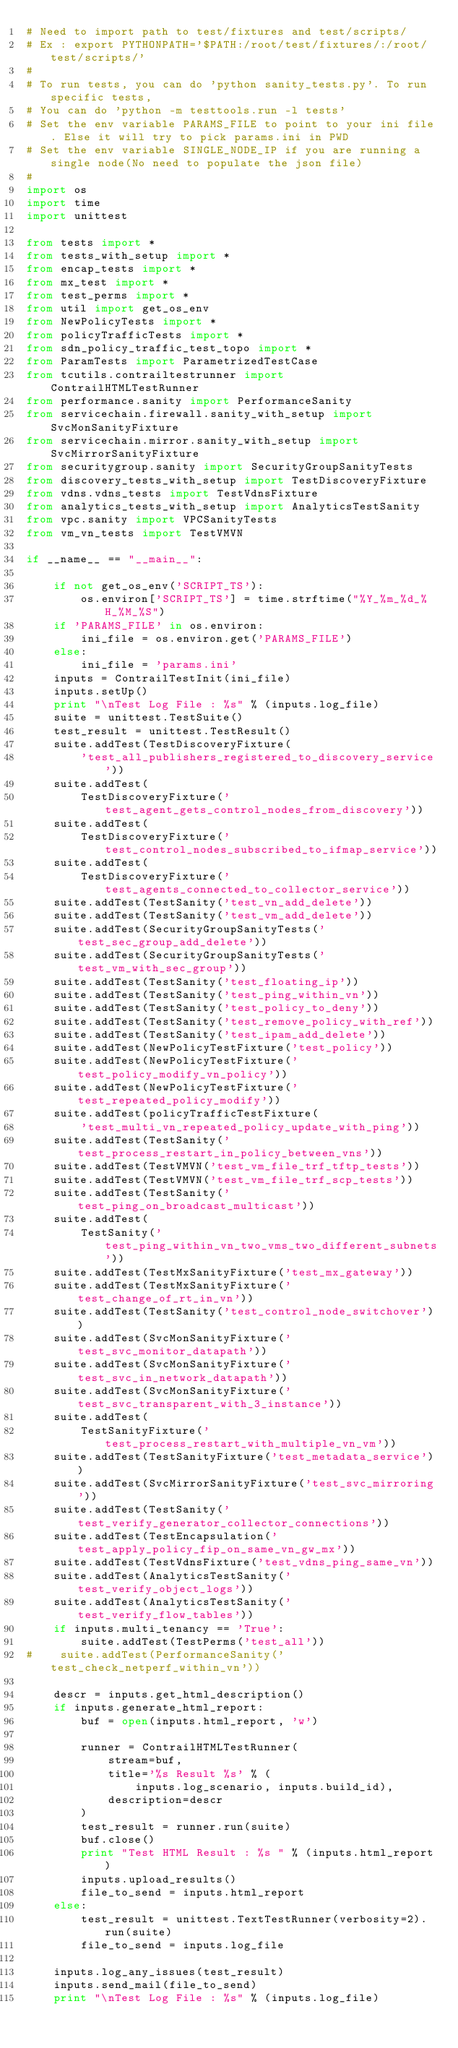<code> <loc_0><loc_0><loc_500><loc_500><_Python_># Need to import path to test/fixtures and test/scripts/
# Ex : export PYTHONPATH='$PATH:/root/test/fixtures/:/root/test/scripts/'
#
# To run tests, you can do 'python sanity_tests.py'. To run specific tests,
# You can do 'python -m testtools.run -l tests'
# Set the env variable PARAMS_FILE to point to your ini file. Else it will try to pick params.ini in PWD
# Set the env variable SINGLE_NODE_IP if you are running a single node(No need to populate the json file)
#
import os
import time
import unittest

from tests import *
from tests_with_setup import *
from encap_tests import *
from mx_test import *
from test_perms import *
from util import get_os_env
from NewPolicyTests import *
from policyTrafficTests import *
from sdn_policy_traffic_test_topo import *
from ParamTests import ParametrizedTestCase
from tcutils.contrailtestrunner import ContrailHTMLTestRunner
from performance.sanity import PerformanceSanity
from servicechain.firewall.sanity_with_setup import SvcMonSanityFixture
from servicechain.mirror.sanity_with_setup import SvcMirrorSanityFixture
from securitygroup.sanity import SecurityGroupSanityTests
from discovery_tests_with_setup import TestDiscoveryFixture
from vdns.vdns_tests import TestVdnsFixture
from analytics_tests_with_setup import AnalyticsTestSanity
from vpc.sanity import VPCSanityTests
from vm_vn_tests import TestVMVN

if __name__ == "__main__":

    if not get_os_env('SCRIPT_TS'):
        os.environ['SCRIPT_TS'] = time.strftime("%Y_%m_%d_%H_%M_%S")
    if 'PARAMS_FILE' in os.environ:
        ini_file = os.environ.get('PARAMS_FILE')
    else:
        ini_file = 'params.ini'
    inputs = ContrailTestInit(ini_file)
    inputs.setUp()
    print "\nTest Log File : %s" % (inputs.log_file)
    suite = unittest.TestSuite()
    test_result = unittest.TestResult()
    suite.addTest(TestDiscoveryFixture(
        'test_all_publishers_registered_to_discovery_service'))
    suite.addTest(
        TestDiscoveryFixture('test_agent_gets_control_nodes_from_discovery'))
    suite.addTest(
        TestDiscoveryFixture('test_control_nodes_subscribed_to_ifmap_service'))
    suite.addTest(
        TestDiscoveryFixture('test_agents_connected_to_collector_service'))
    suite.addTest(TestSanity('test_vn_add_delete'))
    suite.addTest(TestSanity('test_vm_add_delete'))
    suite.addTest(SecurityGroupSanityTests('test_sec_group_add_delete'))
    suite.addTest(SecurityGroupSanityTests('test_vm_with_sec_group'))
    suite.addTest(TestSanity('test_floating_ip'))
    suite.addTest(TestSanity('test_ping_within_vn'))
    suite.addTest(TestSanity('test_policy_to_deny'))
    suite.addTest(TestSanity('test_remove_policy_with_ref'))
    suite.addTest(TestSanity('test_ipam_add_delete'))
    suite.addTest(NewPolicyTestFixture('test_policy'))
    suite.addTest(NewPolicyTestFixture('test_policy_modify_vn_policy'))
    suite.addTest(NewPolicyTestFixture('test_repeated_policy_modify'))
    suite.addTest(policyTrafficTestFixture(
        'test_multi_vn_repeated_policy_update_with_ping'))
    suite.addTest(TestSanity('test_process_restart_in_policy_between_vns'))
    suite.addTest(TestVMVN('test_vm_file_trf_tftp_tests'))
    suite.addTest(TestVMVN('test_vm_file_trf_scp_tests'))
    suite.addTest(TestSanity('test_ping_on_broadcast_multicast'))
    suite.addTest(
        TestSanity('test_ping_within_vn_two_vms_two_different_subnets'))
    suite.addTest(TestMxSanityFixture('test_mx_gateway'))
    suite.addTest(TestMxSanityFixture('test_change_of_rt_in_vn'))
    suite.addTest(TestSanity('test_control_node_switchover'))
    suite.addTest(SvcMonSanityFixture('test_svc_monitor_datapath'))
    suite.addTest(SvcMonSanityFixture('test_svc_in_network_datapath'))
    suite.addTest(SvcMonSanityFixture('test_svc_transparent_with_3_instance'))
    suite.addTest(
        TestSanityFixture('test_process_restart_with_multiple_vn_vm'))
    suite.addTest(TestSanityFixture('test_metadata_service'))
    suite.addTest(SvcMirrorSanityFixture('test_svc_mirroring'))
    suite.addTest(TestSanity('test_verify_generator_collector_connections'))
    suite.addTest(TestEncapsulation('test_apply_policy_fip_on_same_vn_gw_mx'))
    suite.addTest(TestVdnsFixture('test_vdns_ping_same_vn'))
    suite.addTest(AnalyticsTestSanity('test_verify_object_logs'))
    suite.addTest(AnalyticsTestSanity('test_verify_flow_tables'))
    if inputs.multi_tenancy == 'True':
        suite.addTest(TestPerms('test_all'))
#    suite.addTest(PerformanceSanity('test_check_netperf_within_vn'))

    descr = inputs.get_html_description()
    if inputs.generate_html_report:
        buf = open(inputs.html_report, 'w')

        runner = ContrailHTMLTestRunner(
            stream=buf,
            title='%s Result %s' % (
                inputs.log_scenario, inputs.build_id),
            description=descr
        )
        test_result = runner.run(suite)
        buf.close()
        print "Test HTML Result : %s " % (inputs.html_report)
        inputs.upload_results()
        file_to_send = inputs.html_report
    else:
        test_result = unittest.TextTestRunner(verbosity=2).run(suite)
        file_to_send = inputs.log_file

    inputs.log_any_issues(test_result)
    inputs.send_mail(file_to_send)
    print "\nTest Log File : %s" % (inputs.log_file)
</code> 